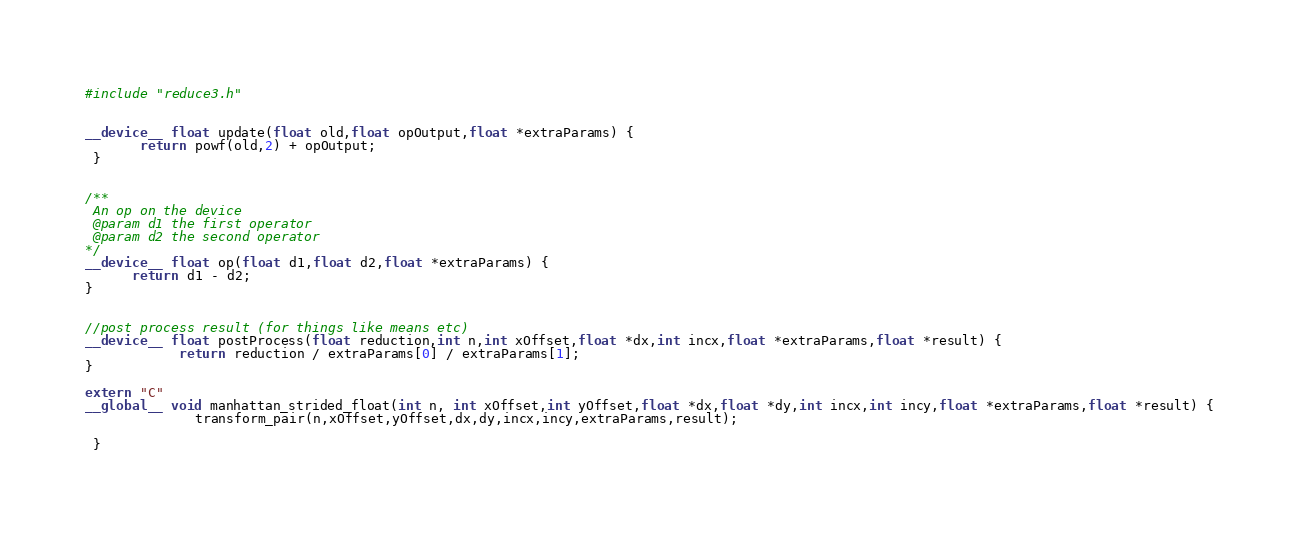Convert code to text. <code><loc_0><loc_0><loc_500><loc_500><_Cuda_>#include "reduce3.h"


__device__ float update(float old,float opOutput,float *extraParams) {
       return powf(old,2) + opOutput;
 }


/**
 An op on the device
 @param d1 the first operator
 @param d2 the second operator
*/
__device__ float op(float d1,float d2,float *extraParams) {
      return d1 - d2;
}


//post process result (for things like means etc)
__device__ float postProcess(float reduction,int n,int xOffset,float *dx,int incx,float *extraParams,float *result) {
            return reduction / extraParams[0] / extraParams[1];
}

extern "C"
__global__ void manhattan_strided_float(int n, int xOffset,int yOffset,float *dx,float *dy,int incx,int incy,float *extraParams,float *result) {
              transform_pair(n,xOffset,yOffset,dx,dy,incx,incy,extraParams,result);

 }


</code> 